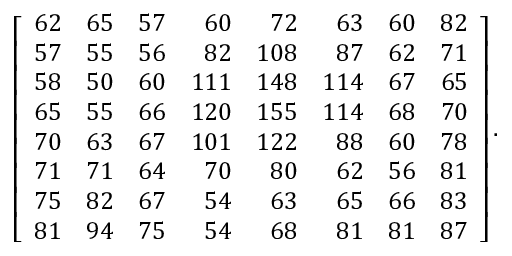<formula> <loc_0><loc_0><loc_500><loc_500>\left [ { \begin{array} { r r r r r r r r } { 6 2 } & { 6 5 } & { 5 7 } & { 6 0 } & { 7 2 } & { 6 3 } & { 6 0 } & { 8 2 } \\ { 5 7 } & { 5 5 } & { 5 6 } & { 8 2 } & { 1 0 8 } & { 8 7 } & { 6 2 } & { 7 1 } \\ { 5 8 } & { 5 0 } & { 6 0 } & { 1 1 1 } & { 1 4 8 } & { 1 1 4 } & { 6 7 } & { 6 5 } \\ { 6 5 } & { 5 5 } & { 6 6 } & { 1 2 0 } & { 1 5 5 } & { 1 1 4 } & { 6 8 } & { 7 0 } \\ { 7 0 } & { 6 3 } & { 6 7 } & { 1 0 1 } & { 1 2 2 } & { 8 8 } & { 6 0 } & { 7 8 } \\ { 7 1 } & { 7 1 } & { 6 4 } & { 7 0 } & { 8 0 } & { 6 2 } & { 5 6 } & { 8 1 } \\ { 7 5 } & { 8 2 } & { 6 7 } & { 5 4 } & { 6 3 } & { 6 5 } & { 6 6 } & { 8 3 } \\ { 8 1 } & { 9 4 } & { 7 5 } & { 5 4 } & { 6 8 } & { 8 1 } & { 8 1 } & { 8 7 } \end{array} } \right ] .</formula> 